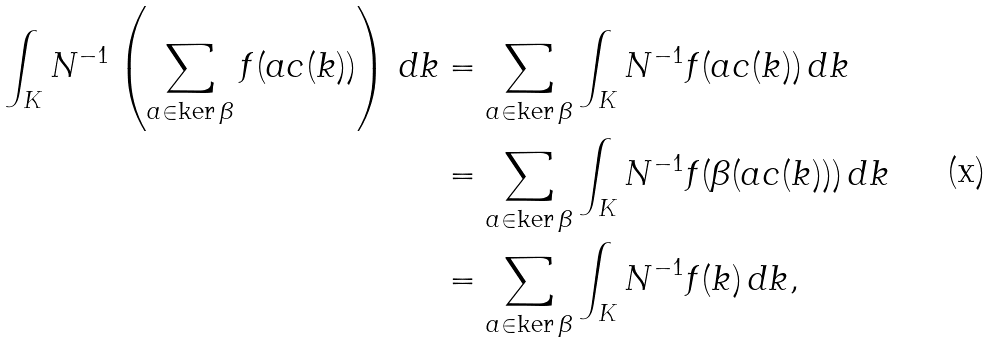<formula> <loc_0><loc_0><loc_500><loc_500>\int _ { K } N ^ { - 1 } \left ( \sum _ { a \in \ker \beta } f ( a c ( k ) ) \right ) \, d k & = \sum _ { a \in \ker \beta } \int _ { K } N ^ { - 1 } f ( a c ( k ) ) \, d k \\ & = \sum _ { a \in \ker \beta } \int _ { K } N ^ { - 1 } f ( \beta ( a c ( k ) ) ) \, d k \\ & = \sum _ { a \in \ker \beta } \int _ { K } N ^ { - 1 } f ( k ) \, d k ,</formula> 